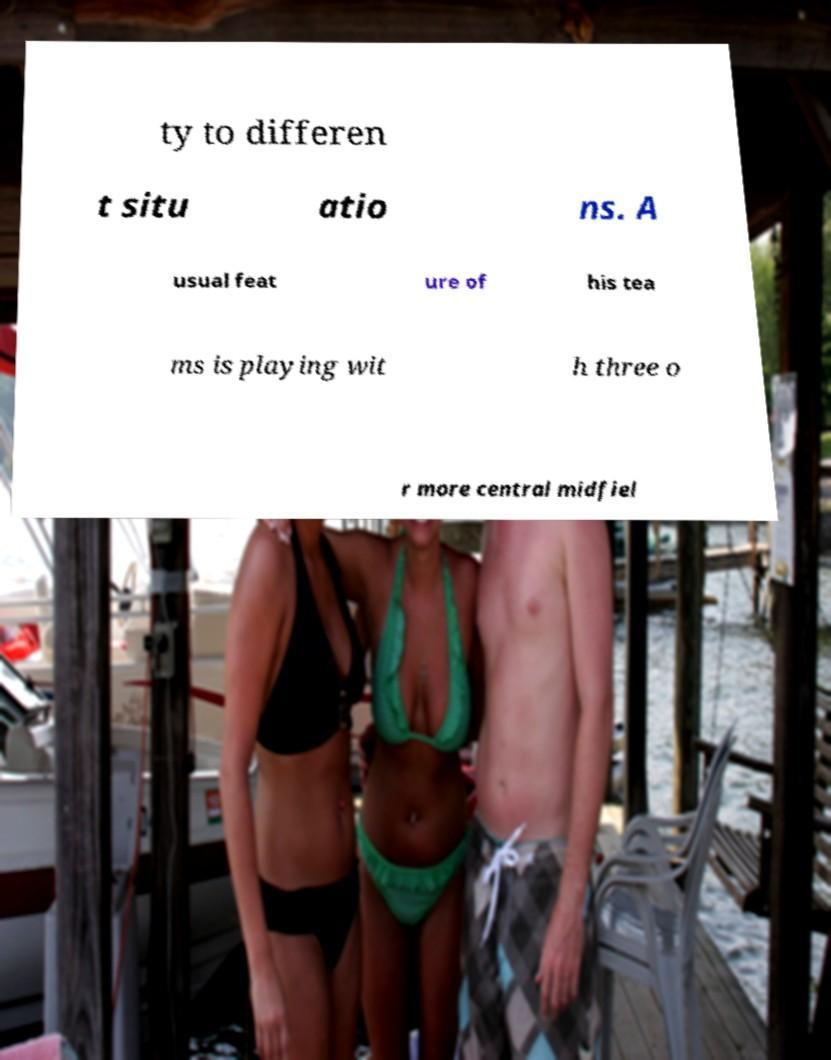Can you accurately transcribe the text from the provided image for me? ty to differen t situ atio ns. A usual feat ure of his tea ms is playing wit h three o r more central midfiel 